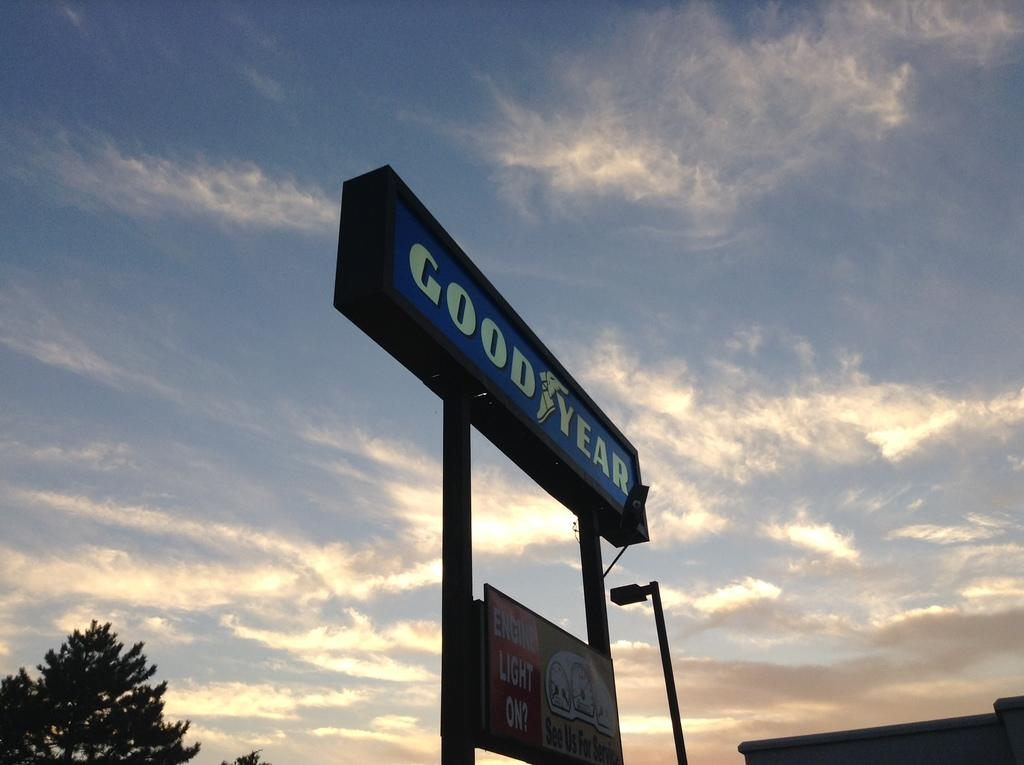Provide a one-sentence caption for the provided image. A large sign advertising Good year is shown in the blue sky background. 